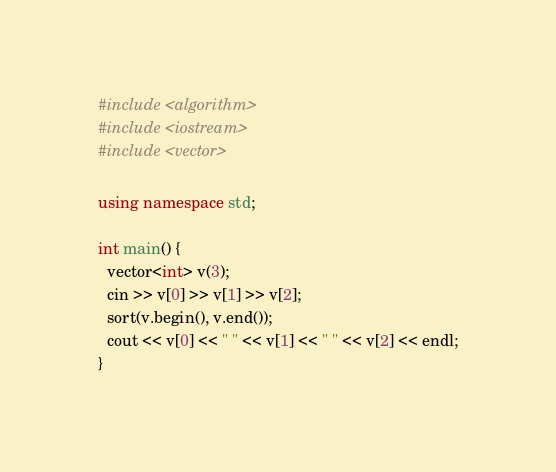Convert code to text. <code><loc_0><loc_0><loc_500><loc_500><_C++_>#include <algorithm>
#include <iostream>
#include <vector>

using namespace std;

int main() {
  vector<int> v(3);
  cin >> v[0] >> v[1] >> v[2];
  sort(v.begin(), v.end());
  cout << v[0] << " " << v[1] << " " << v[2] << endl;
}</code> 